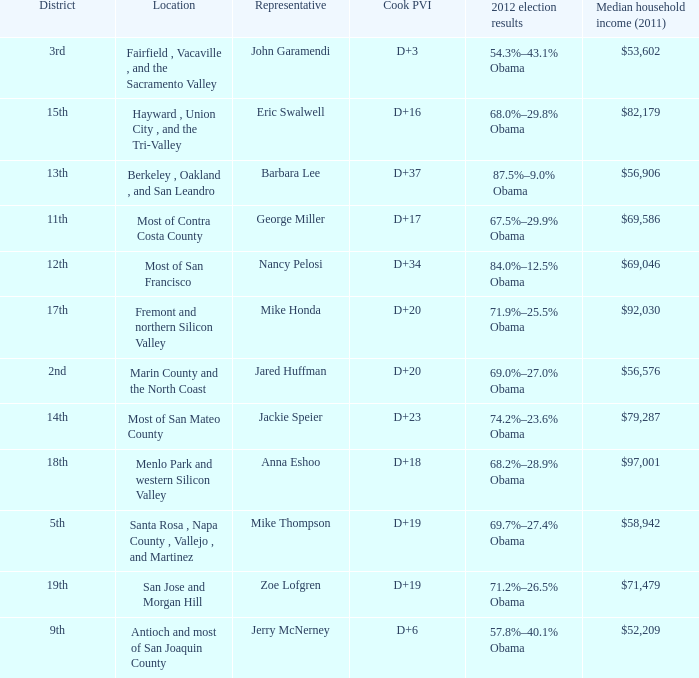What is the Cook PVI for the location that has a representative of Mike Thompson? D+19. Would you mind parsing the complete table? {'header': ['District', 'Location', 'Representative', 'Cook PVI', '2012 election results', 'Median household income (2011)'], 'rows': [['3rd', 'Fairfield , Vacaville , and the Sacramento Valley', 'John Garamendi', 'D+3', '54.3%–43.1% Obama', '$53,602'], ['15th', 'Hayward , Union City , and the Tri-Valley', 'Eric Swalwell', 'D+16', '68.0%–29.8% Obama', '$82,179'], ['13th', 'Berkeley , Oakland , and San Leandro', 'Barbara Lee', 'D+37', '87.5%–9.0% Obama', '$56,906'], ['11th', 'Most of Contra Costa County', 'George Miller', 'D+17', '67.5%–29.9% Obama', '$69,586'], ['12th', 'Most of San Francisco', 'Nancy Pelosi', 'D+34', '84.0%–12.5% Obama', '$69,046'], ['17th', 'Fremont and northern Silicon Valley', 'Mike Honda', 'D+20', '71.9%–25.5% Obama', '$92,030'], ['2nd', 'Marin County and the North Coast', 'Jared Huffman', 'D+20', '69.0%–27.0% Obama', '$56,576'], ['14th', 'Most of San Mateo County', 'Jackie Speier', 'D+23', '74.2%–23.6% Obama', '$79,287'], ['18th', 'Menlo Park and western Silicon Valley', 'Anna Eshoo', 'D+18', '68.2%–28.9% Obama', '$97,001'], ['5th', 'Santa Rosa , Napa County , Vallejo , and Martinez', 'Mike Thompson', 'D+19', '69.7%–27.4% Obama', '$58,942'], ['19th', 'San Jose and Morgan Hill', 'Zoe Lofgren', 'D+19', '71.2%–26.5% Obama', '$71,479'], ['9th', 'Antioch and most of San Joaquin County', 'Jerry McNerney', 'D+6', '57.8%–40.1% Obama', '$52,209']]} 